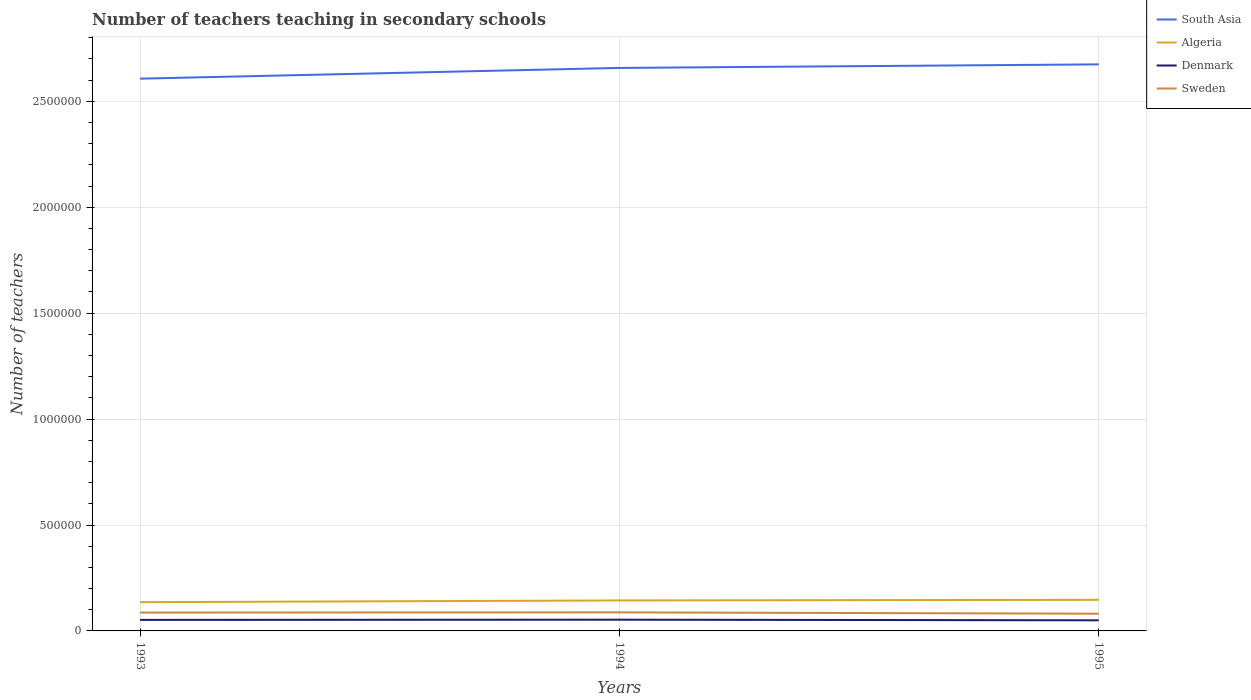How many different coloured lines are there?
Keep it short and to the point. 4. Is the number of lines equal to the number of legend labels?
Keep it short and to the point. Yes. Across all years, what is the maximum number of teachers teaching in secondary schools in Sweden?
Offer a terse response. 8.14e+04. What is the total number of teachers teaching in secondary schools in South Asia in the graph?
Offer a very short reply. -1.68e+04. What is the difference between the highest and the second highest number of teachers teaching in secondary schools in Sweden?
Your answer should be compact. 6160. What is the difference between the highest and the lowest number of teachers teaching in secondary schools in Algeria?
Your response must be concise. 2. Is the number of teachers teaching in secondary schools in Algeria strictly greater than the number of teachers teaching in secondary schools in Sweden over the years?
Make the answer very short. No. How many lines are there?
Provide a short and direct response. 4. Are the values on the major ticks of Y-axis written in scientific E-notation?
Give a very brief answer. No. Does the graph contain any zero values?
Ensure brevity in your answer.  No. Where does the legend appear in the graph?
Keep it short and to the point. Top right. What is the title of the graph?
Offer a terse response. Number of teachers teaching in secondary schools. What is the label or title of the Y-axis?
Provide a short and direct response. Number of teachers. What is the Number of teachers of South Asia in 1993?
Your answer should be very brief. 2.61e+06. What is the Number of teachers of Algeria in 1993?
Provide a short and direct response. 1.36e+05. What is the Number of teachers in Denmark in 1993?
Provide a short and direct response. 5.21e+04. What is the Number of teachers of Sweden in 1993?
Provide a succinct answer. 8.66e+04. What is the Number of teachers in South Asia in 1994?
Offer a terse response. 2.66e+06. What is the Number of teachers of Algeria in 1994?
Make the answer very short. 1.44e+05. What is the Number of teachers of Denmark in 1994?
Keep it short and to the point. 5.30e+04. What is the Number of teachers in Sweden in 1994?
Ensure brevity in your answer.  8.75e+04. What is the Number of teachers in South Asia in 1995?
Give a very brief answer. 2.67e+06. What is the Number of teachers of Algeria in 1995?
Provide a short and direct response. 1.47e+05. What is the Number of teachers in Denmark in 1995?
Offer a terse response. 5.01e+04. What is the Number of teachers in Sweden in 1995?
Offer a very short reply. 8.14e+04. Across all years, what is the maximum Number of teachers of South Asia?
Offer a terse response. 2.67e+06. Across all years, what is the maximum Number of teachers in Algeria?
Keep it short and to the point. 1.47e+05. Across all years, what is the maximum Number of teachers of Denmark?
Offer a terse response. 5.30e+04. Across all years, what is the maximum Number of teachers in Sweden?
Keep it short and to the point. 8.75e+04. Across all years, what is the minimum Number of teachers in South Asia?
Your answer should be very brief. 2.61e+06. Across all years, what is the minimum Number of teachers of Algeria?
Offer a terse response. 1.36e+05. Across all years, what is the minimum Number of teachers in Denmark?
Offer a terse response. 5.01e+04. Across all years, what is the minimum Number of teachers in Sweden?
Provide a short and direct response. 8.14e+04. What is the total Number of teachers of South Asia in the graph?
Make the answer very short. 7.94e+06. What is the total Number of teachers in Algeria in the graph?
Keep it short and to the point. 4.26e+05. What is the total Number of teachers of Denmark in the graph?
Make the answer very short. 1.55e+05. What is the total Number of teachers of Sweden in the graph?
Keep it short and to the point. 2.56e+05. What is the difference between the Number of teachers of South Asia in 1993 and that in 1994?
Make the answer very short. -5.07e+04. What is the difference between the Number of teachers of Algeria in 1993 and that in 1994?
Make the answer very short. -8157. What is the difference between the Number of teachers of Denmark in 1993 and that in 1994?
Make the answer very short. -900. What is the difference between the Number of teachers of Sweden in 1993 and that in 1994?
Provide a short and direct response. -895. What is the difference between the Number of teachers in South Asia in 1993 and that in 1995?
Your response must be concise. -6.75e+04. What is the difference between the Number of teachers of Algeria in 1993 and that in 1995?
Give a very brief answer. -1.11e+04. What is the difference between the Number of teachers of Denmark in 1993 and that in 1995?
Provide a succinct answer. 2000. What is the difference between the Number of teachers of Sweden in 1993 and that in 1995?
Ensure brevity in your answer.  5265. What is the difference between the Number of teachers in South Asia in 1994 and that in 1995?
Provide a short and direct response. -1.68e+04. What is the difference between the Number of teachers in Algeria in 1994 and that in 1995?
Provide a succinct answer. -2905. What is the difference between the Number of teachers in Denmark in 1994 and that in 1995?
Your response must be concise. 2900. What is the difference between the Number of teachers in Sweden in 1994 and that in 1995?
Make the answer very short. 6160. What is the difference between the Number of teachers in South Asia in 1993 and the Number of teachers in Algeria in 1994?
Make the answer very short. 2.46e+06. What is the difference between the Number of teachers of South Asia in 1993 and the Number of teachers of Denmark in 1994?
Give a very brief answer. 2.55e+06. What is the difference between the Number of teachers in South Asia in 1993 and the Number of teachers in Sweden in 1994?
Keep it short and to the point. 2.52e+06. What is the difference between the Number of teachers in Algeria in 1993 and the Number of teachers in Denmark in 1994?
Your answer should be compact. 8.27e+04. What is the difference between the Number of teachers of Algeria in 1993 and the Number of teachers of Sweden in 1994?
Provide a short and direct response. 4.82e+04. What is the difference between the Number of teachers of Denmark in 1993 and the Number of teachers of Sweden in 1994?
Make the answer very short. -3.54e+04. What is the difference between the Number of teachers of South Asia in 1993 and the Number of teachers of Algeria in 1995?
Your answer should be compact. 2.46e+06. What is the difference between the Number of teachers in South Asia in 1993 and the Number of teachers in Denmark in 1995?
Your answer should be compact. 2.56e+06. What is the difference between the Number of teachers in South Asia in 1993 and the Number of teachers in Sweden in 1995?
Offer a terse response. 2.53e+06. What is the difference between the Number of teachers of Algeria in 1993 and the Number of teachers of Denmark in 1995?
Your response must be concise. 8.56e+04. What is the difference between the Number of teachers of Algeria in 1993 and the Number of teachers of Sweden in 1995?
Provide a short and direct response. 5.43e+04. What is the difference between the Number of teachers of Denmark in 1993 and the Number of teachers of Sweden in 1995?
Offer a very short reply. -2.93e+04. What is the difference between the Number of teachers of South Asia in 1994 and the Number of teachers of Algeria in 1995?
Offer a terse response. 2.51e+06. What is the difference between the Number of teachers in South Asia in 1994 and the Number of teachers in Denmark in 1995?
Offer a terse response. 2.61e+06. What is the difference between the Number of teachers of South Asia in 1994 and the Number of teachers of Sweden in 1995?
Offer a terse response. 2.58e+06. What is the difference between the Number of teachers in Algeria in 1994 and the Number of teachers in Denmark in 1995?
Keep it short and to the point. 9.38e+04. What is the difference between the Number of teachers of Algeria in 1994 and the Number of teachers of Sweden in 1995?
Offer a very short reply. 6.25e+04. What is the difference between the Number of teachers of Denmark in 1994 and the Number of teachers of Sweden in 1995?
Your answer should be very brief. -2.84e+04. What is the average Number of teachers of South Asia per year?
Your answer should be compact. 2.65e+06. What is the average Number of teachers of Algeria per year?
Offer a very short reply. 1.42e+05. What is the average Number of teachers in Denmark per year?
Ensure brevity in your answer.  5.17e+04. What is the average Number of teachers in Sweden per year?
Provide a succinct answer. 8.52e+04. In the year 1993, what is the difference between the Number of teachers in South Asia and Number of teachers in Algeria?
Keep it short and to the point. 2.47e+06. In the year 1993, what is the difference between the Number of teachers in South Asia and Number of teachers in Denmark?
Your response must be concise. 2.55e+06. In the year 1993, what is the difference between the Number of teachers in South Asia and Number of teachers in Sweden?
Keep it short and to the point. 2.52e+06. In the year 1993, what is the difference between the Number of teachers of Algeria and Number of teachers of Denmark?
Keep it short and to the point. 8.36e+04. In the year 1993, what is the difference between the Number of teachers in Algeria and Number of teachers in Sweden?
Offer a terse response. 4.91e+04. In the year 1993, what is the difference between the Number of teachers of Denmark and Number of teachers of Sweden?
Offer a terse response. -3.46e+04. In the year 1994, what is the difference between the Number of teachers in South Asia and Number of teachers in Algeria?
Keep it short and to the point. 2.51e+06. In the year 1994, what is the difference between the Number of teachers in South Asia and Number of teachers in Denmark?
Your answer should be compact. 2.60e+06. In the year 1994, what is the difference between the Number of teachers in South Asia and Number of teachers in Sweden?
Ensure brevity in your answer.  2.57e+06. In the year 1994, what is the difference between the Number of teachers in Algeria and Number of teachers in Denmark?
Keep it short and to the point. 9.09e+04. In the year 1994, what is the difference between the Number of teachers of Algeria and Number of teachers of Sweden?
Your answer should be compact. 5.63e+04. In the year 1994, what is the difference between the Number of teachers of Denmark and Number of teachers of Sweden?
Your response must be concise. -3.45e+04. In the year 1995, what is the difference between the Number of teachers in South Asia and Number of teachers in Algeria?
Your answer should be very brief. 2.53e+06. In the year 1995, what is the difference between the Number of teachers in South Asia and Number of teachers in Denmark?
Ensure brevity in your answer.  2.62e+06. In the year 1995, what is the difference between the Number of teachers in South Asia and Number of teachers in Sweden?
Your answer should be compact. 2.59e+06. In the year 1995, what is the difference between the Number of teachers of Algeria and Number of teachers of Denmark?
Ensure brevity in your answer.  9.67e+04. In the year 1995, what is the difference between the Number of teachers in Algeria and Number of teachers in Sweden?
Give a very brief answer. 6.54e+04. In the year 1995, what is the difference between the Number of teachers of Denmark and Number of teachers of Sweden?
Give a very brief answer. -3.13e+04. What is the ratio of the Number of teachers of South Asia in 1993 to that in 1994?
Provide a succinct answer. 0.98. What is the ratio of the Number of teachers of Algeria in 1993 to that in 1994?
Keep it short and to the point. 0.94. What is the ratio of the Number of teachers in Denmark in 1993 to that in 1994?
Your answer should be compact. 0.98. What is the ratio of the Number of teachers of Sweden in 1993 to that in 1994?
Give a very brief answer. 0.99. What is the ratio of the Number of teachers in South Asia in 1993 to that in 1995?
Keep it short and to the point. 0.97. What is the ratio of the Number of teachers of Algeria in 1993 to that in 1995?
Give a very brief answer. 0.92. What is the ratio of the Number of teachers of Denmark in 1993 to that in 1995?
Offer a very short reply. 1.04. What is the ratio of the Number of teachers in Sweden in 1993 to that in 1995?
Your answer should be compact. 1.06. What is the ratio of the Number of teachers in Algeria in 1994 to that in 1995?
Give a very brief answer. 0.98. What is the ratio of the Number of teachers in Denmark in 1994 to that in 1995?
Offer a very short reply. 1.06. What is the ratio of the Number of teachers of Sweden in 1994 to that in 1995?
Make the answer very short. 1.08. What is the difference between the highest and the second highest Number of teachers of South Asia?
Provide a short and direct response. 1.68e+04. What is the difference between the highest and the second highest Number of teachers of Algeria?
Provide a succinct answer. 2905. What is the difference between the highest and the second highest Number of teachers of Denmark?
Provide a succinct answer. 900. What is the difference between the highest and the second highest Number of teachers in Sweden?
Make the answer very short. 895. What is the difference between the highest and the lowest Number of teachers in South Asia?
Provide a short and direct response. 6.75e+04. What is the difference between the highest and the lowest Number of teachers of Algeria?
Your answer should be very brief. 1.11e+04. What is the difference between the highest and the lowest Number of teachers of Denmark?
Your answer should be very brief. 2900. What is the difference between the highest and the lowest Number of teachers in Sweden?
Your answer should be compact. 6160. 